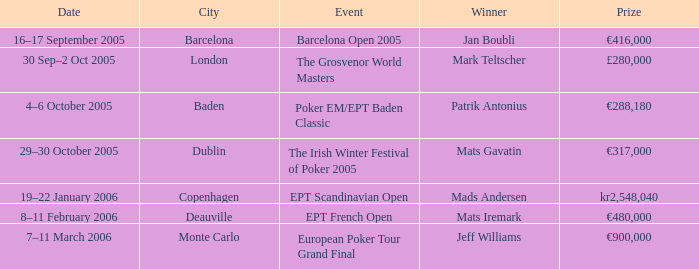What city did an event have a prize of €288,180? Baden. 